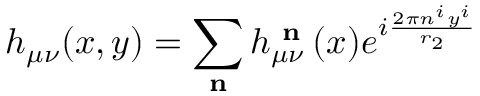Convert formula to latex. <formula><loc_0><loc_0><loc_500><loc_500>h _ { \mu \nu } ( x , y ) = \sum _ { n } h _ { \mu \nu } ^ { n } ( x ) e ^ { i \frac { 2 \pi n ^ { i } y ^ { i } } { r _ { 2 } } }</formula> 